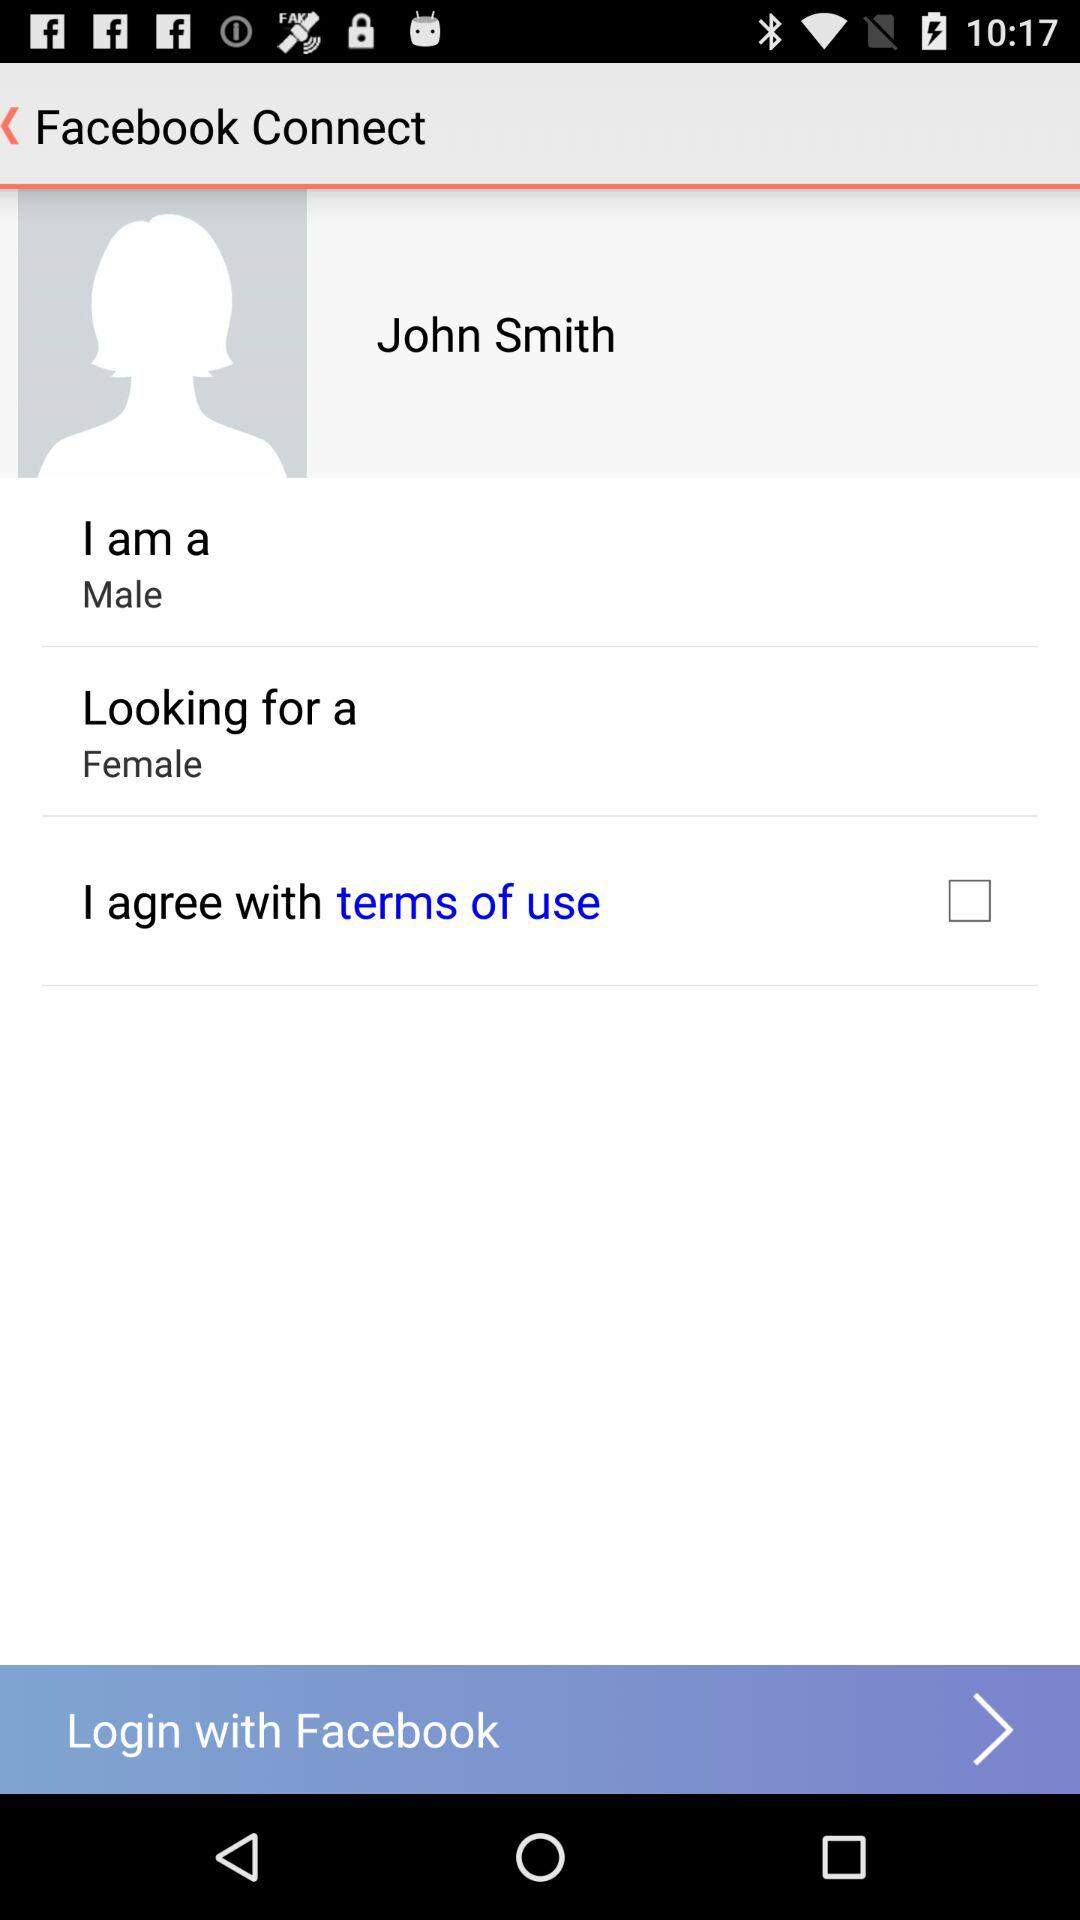What is the name of the user? The name of the user is John Smith. 